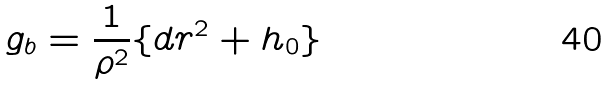<formula> <loc_0><loc_0><loc_500><loc_500>g _ { b } = \frac { 1 } { \rho ^ { 2 } } \{ d r ^ { 2 } + h _ { 0 } \}</formula> 